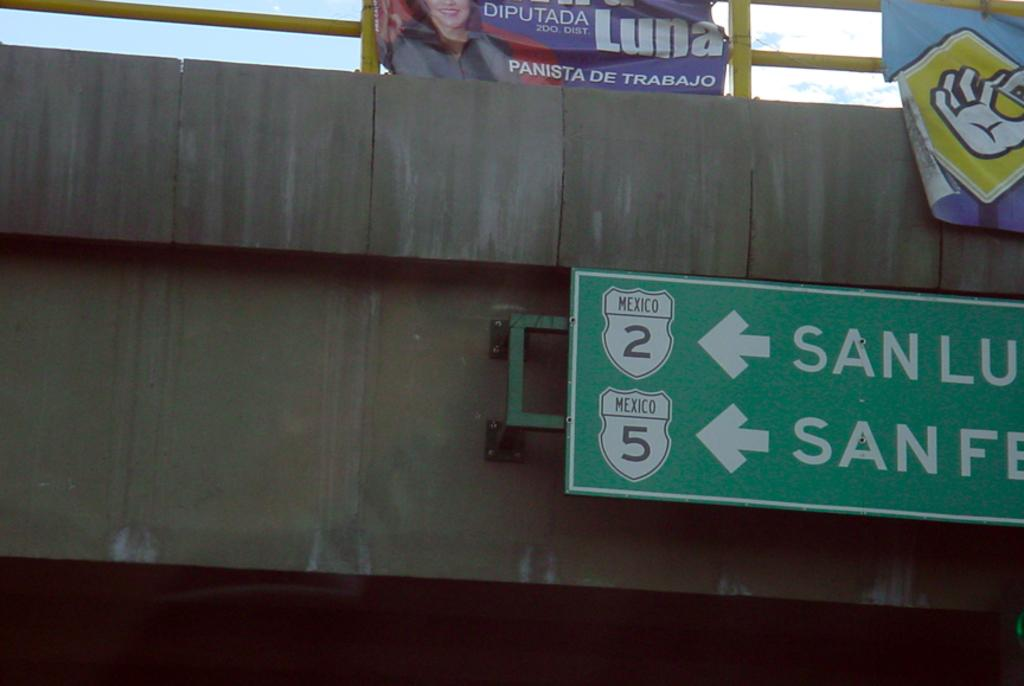<image>
Render a clear and concise summary of the photo. A highway overpass with left turn signals to get on Highway 2 or Highway 5. 